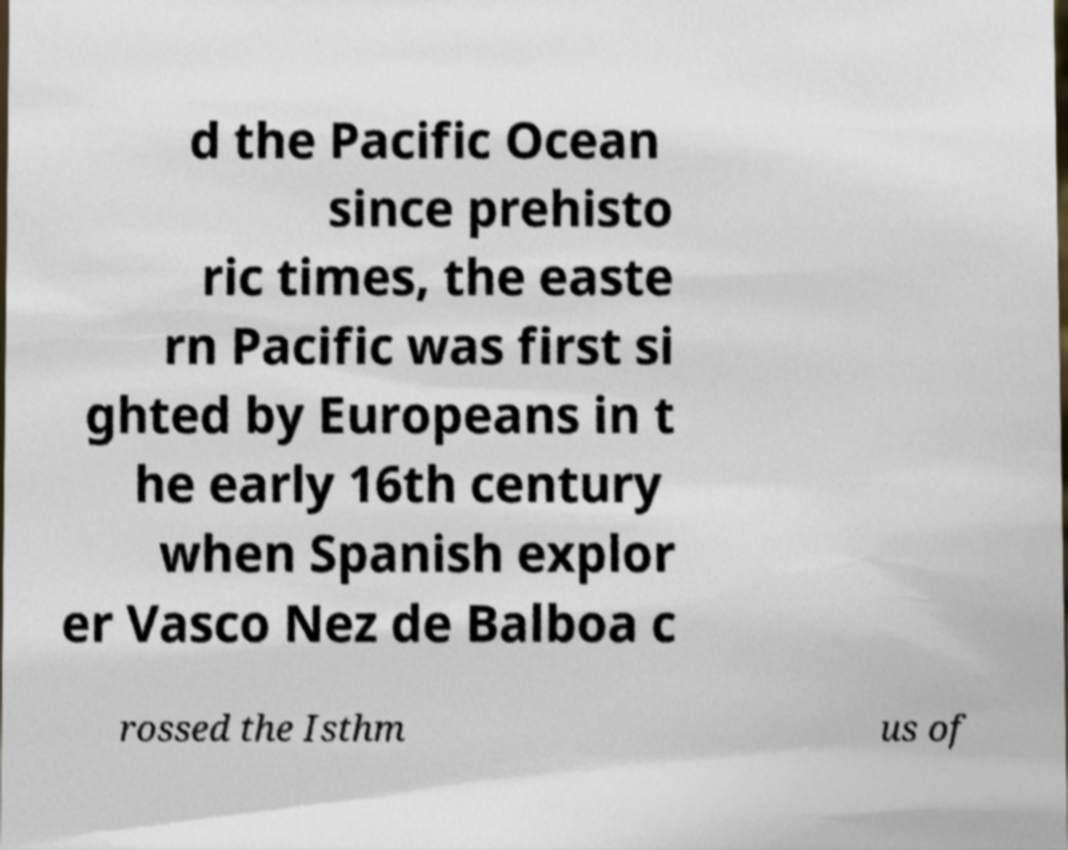For documentation purposes, I need the text within this image transcribed. Could you provide that? d the Pacific Ocean since prehisto ric times, the easte rn Pacific was first si ghted by Europeans in t he early 16th century when Spanish explor er Vasco Nez de Balboa c rossed the Isthm us of 